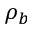<formula> <loc_0><loc_0><loc_500><loc_500>\rho _ { b }</formula> 